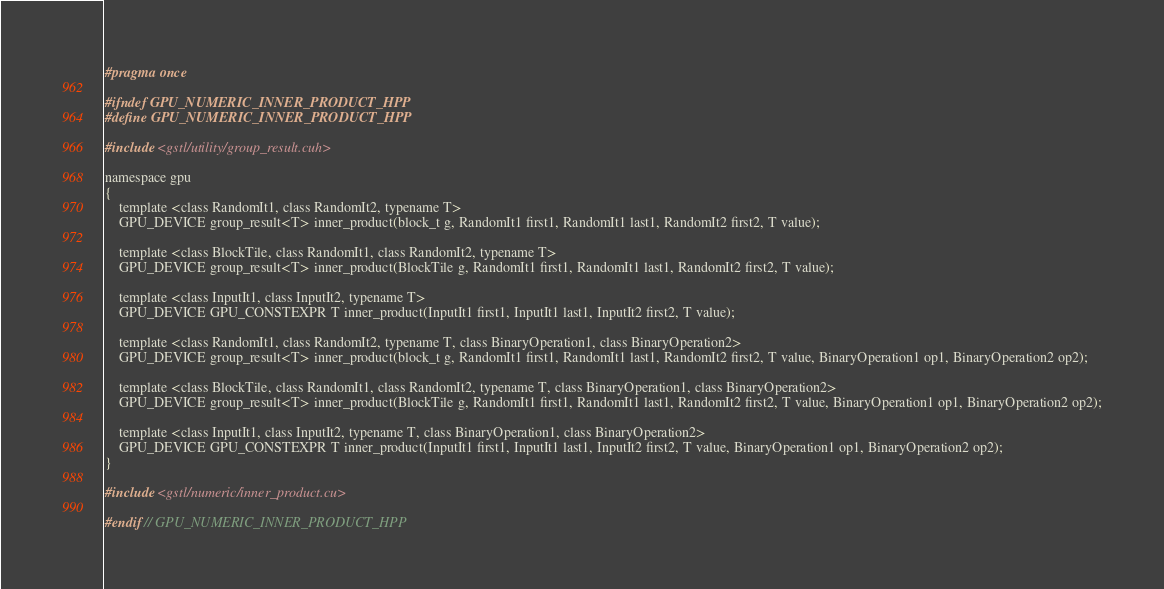Convert code to text. <code><loc_0><loc_0><loc_500><loc_500><_Cuda_>#pragma once

#ifndef GPU_NUMERIC_INNER_PRODUCT_HPP
#define GPU_NUMERIC_INNER_PRODUCT_HPP

#include <gstl/utility/group_result.cuh>

namespace gpu
{
	template <class RandomIt1, class RandomIt2, typename T>
	GPU_DEVICE group_result<T> inner_product(block_t g, RandomIt1 first1, RandomIt1 last1, RandomIt2 first2, T value);

	template <class BlockTile, class RandomIt1, class RandomIt2, typename T>
	GPU_DEVICE group_result<T> inner_product(BlockTile g, RandomIt1 first1, RandomIt1 last1, RandomIt2 first2, T value);

	template <class InputIt1, class InputIt2, typename T>
	GPU_DEVICE GPU_CONSTEXPR T inner_product(InputIt1 first1, InputIt1 last1, InputIt2 first2, T value);

	template <class RandomIt1, class RandomIt2, typename T, class BinaryOperation1, class BinaryOperation2>
	GPU_DEVICE group_result<T> inner_product(block_t g, RandomIt1 first1, RandomIt1 last1, RandomIt2 first2, T value, BinaryOperation1 op1, BinaryOperation2 op2);

	template <class BlockTile, class RandomIt1, class RandomIt2, typename T, class BinaryOperation1, class BinaryOperation2>
	GPU_DEVICE group_result<T> inner_product(BlockTile g, RandomIt1 first1, RandomIt1 last1, RandomIt2 first2, T value, BinaryOperation1 op1, BinaryOperation2 op2);

	template <class InputIt1, class InputIt2, typename T, class BinaryOperation1, class BinaryOperation2>
	GPU_DEVICE GPU_CONSTEXPR T inner_product(InputIt1 first1, InputIt1 last1, InputIt2 first2, T value, BinaryOperation1 op1, BinaryOperation2 op2);
}

#include <gstl/numeric/inner_product.cu>

#endif // GPU_NUMERIC_INNER_PRODUCT_HPP
</code> 